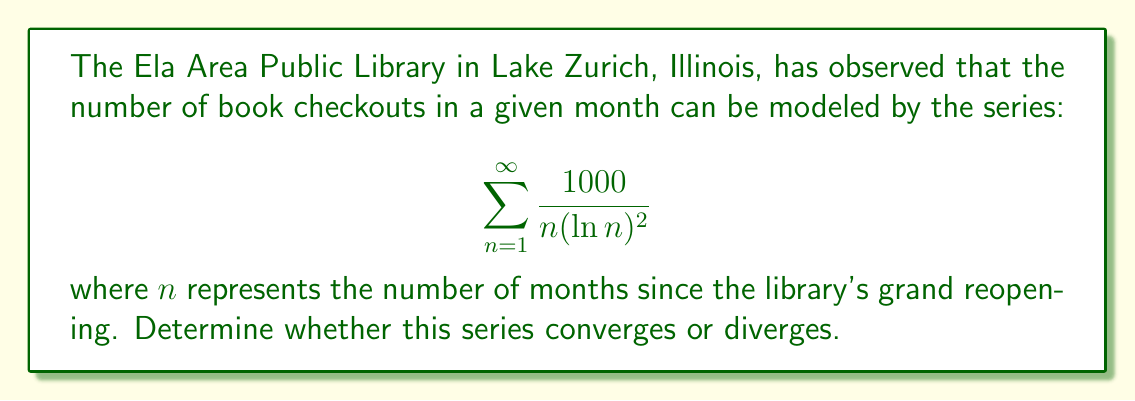Provide a solution to this math problem. To determine the convergence of this series, we can use the integral test. Let's follow these steps:

1) First, we define the function $f(x) = \frac{1000}{x(\ln x)^2}$ for $x \geq 2$.

2) We need to check if $f(x)$ is continuous, positive, and decreasing on $[2,\infty)$:
   - $f(x)$ is continuous for $x \geq 2$
   - $f(x)$ is always positive for $x \geq 2$
   - To check if it's decreasing, we can take the derivative:
     $$f'(x) = -\frac{1000}{x^2(\ln x)^2} - \frac{2000}{x^2(\ln x)^3}$$
     This is negative for $x \geq 2$, so $f(x)$ is decreasing.

3) Now we can apply the integral test. The series converges if and only if the following improper integral converges:

   $$\int_2^{\infty} \frac{1000}{x(\ln x)^2} dx$$

4) To evaluate this integral, we can use the substitution $u = \ln x$:
   
   $x = e^u$, $dx = e^u du$
   
   When $x = 2$, $u = \ln 2$
   When $x \to \infty$, $u \to \infty$

5) Substituting:

   $$\int_{\ln 2}^{\infty} \frac{1000}{e^u u^2} e^u du = 1000 \int_{\ln 2}^{\infty} \frac{1}{u^2} du$$

6) Evaluating this integral:

   $$1000 \left[-\frac{1}{u}\right]_{\ln 2}^{\infty} = 1000 \left(0 + \frac{1}{\ln 2}\right) = \frac{1000}{\ln 2}$$

7) Since this improper integral converges to a finite value, by the integral test, the original series converges.
Answer: The series $\sum_{n=1}^{\infty} \frac{1000}{n(\ln n)^2}$ converges. 